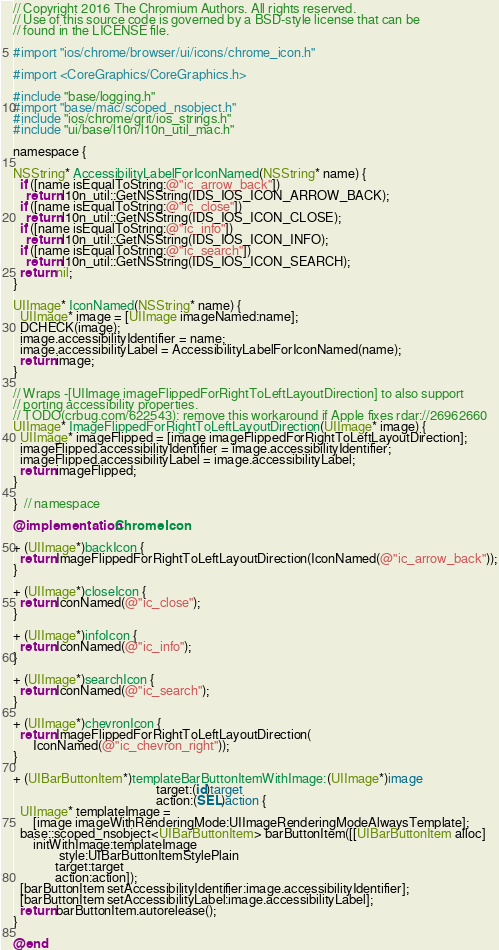<code> <loc_0><loc_0><loc_500><loc_500><_ObjectiveC_>// Copyright 2016 The Chromium Authors. All rights reserved.
// Use of this source code is governed by a BSD-style license that can be
// found in the LICENSE file.

#import "ios/chrome/browser/ui/icons/chrome_icon.h"

#import <CoreGraphics/CoreGraphics.h>

#include "base/logging.h"
#import "base/mac/scoped_nsobject.h"
#include "ios/chrome/grit/ios_strings.h"
#include "ui/base/l10n/l10n_util_mac.h"

namespace {

NSString* AccessibilityLabelForIconNamed(NSString* name) {
  if ([name isEqualToString:@"ic_arrow_back"])
    return l10n_util::GetNSString(IDS_IOS_ICON_ARROW_BACK);
  if ([name isEqualToString:@"ic_close"])
    return l10n_util::GetNSString(IDS_IOS_ICON_CLOSE);
  if ([name isEqualToString:@"ic_info"])
    return l10n_util::GetNSString(IDS_IOS_ICON_INFO);
  if ([name isEqualToString:@"ic_search"])
    return l10n_util::GetNSString(IDS_IOS_ICON_SEARCH);
  return nil;
}

UIImage* IconNamed(NSString* name) {
  UIImage* image = [UIImage imageNamed:name];
  DCHECK(image);
  image.accessibilityIdentifier = name;
  image.accessibilityLabel = AccessibilityLabelForIconNamed(name);
  return image;
}

// Wraps -[UIImage imageFlippedForRightToLeftLayoutDirection] to also support
// porting accessibility properties.
// TODO(crbug.com/622543): remove this workaround if Apple fixes rdar://26962660
UIImage* ImageFlippedForRightToLeftLayoutDirection(UIImage* image) {
  UIImage* imageFlipped = [image imageFlippedForRightToLeftLayoutDirection];
  imageFlipped.accessibilityIdentifier = image.accessibilityIdentifier;
  imageFlipped.accessibilityLabel = image.accessibilityLabel;
  return imageFlipped;
}

}  // namespace

@implementation ChromeIcon

+ (UIImage*)backIcon {
  return ImageFlippedForRightToLeftLayoutDirection(IconNamed(@"ic_arrow_back"));
}

+ (UIImage*)closeIcon {
  return IconNamed(@"ic_close");
}

+ (UIImage*)infoIcon {
  return IconNamed(@"ic_info");
}

+ (UIImage*)searchIcon {
  return IconNamed(@"ic_search");
}

+ (UIImage*)chevronIcon {
  return ImageFlippedForRightToLeftLayoutDirection(
      IconNamed(@"ic_chevron_right"));
}

+ (UIBarButtonItem*)templateBarButtonItemWithImage:(UIImage*)image
                                            target:(id)target
                                            action:(SEL)action {
  UIImage* templateImage =
      [image imageWithRenderingMode:UIImageRenderingModeAlwaysTemplate];
  base::scoped_nsobject<UIBarButtonItem> barButtonItem([[UIBarButtonItem alloc]
      initWithImage:templateImage
              style:UIBarButtonItemStylePlain
             target:target
             action:action]);
  [barButtonItem setAccessibilityIdentifier:image.accessibilityIdentifier];
  [barButtonItem setAccessibilityLabel:image.accessibilityLabel];
  return barButtonItem.autorelease();
}

@end
</code> 